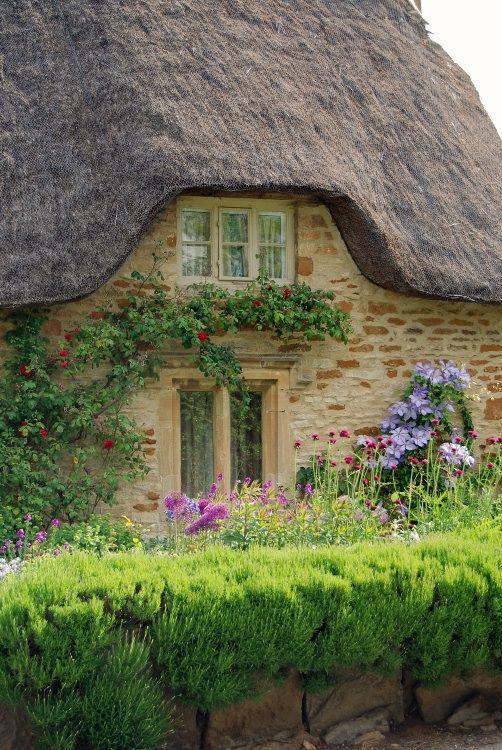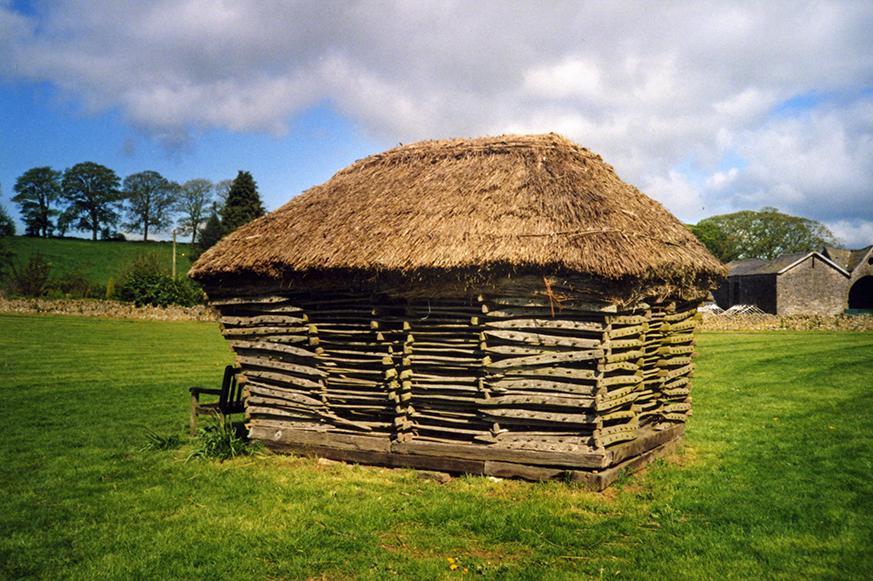The first image is the image on the left, the second image is the image on the right. Assess this claim about the two images: "The right image shows a simple square structure with a sloping shaggy thatched roof that has a flat ridge on top, sitting on a green field with no landscaping around it.". Correct or not? Answer yes or no. Yes. The first image is the image on the left, the second image is the image on the right. Given the left and right images, does the statement "In at least one image there is a small outside shed with hay for the roof and wood for the sides." hold true? Answer yes or no. Yes. 